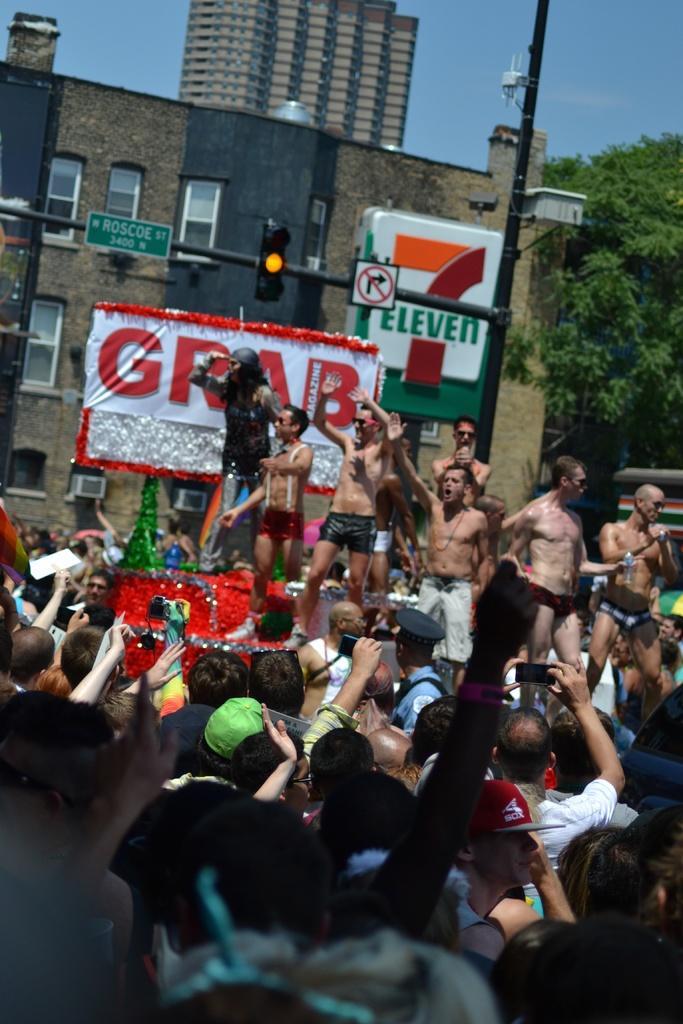Describe this image in one or two sentences. In this image there are many people. There are buildings and trees. There is a sky. 